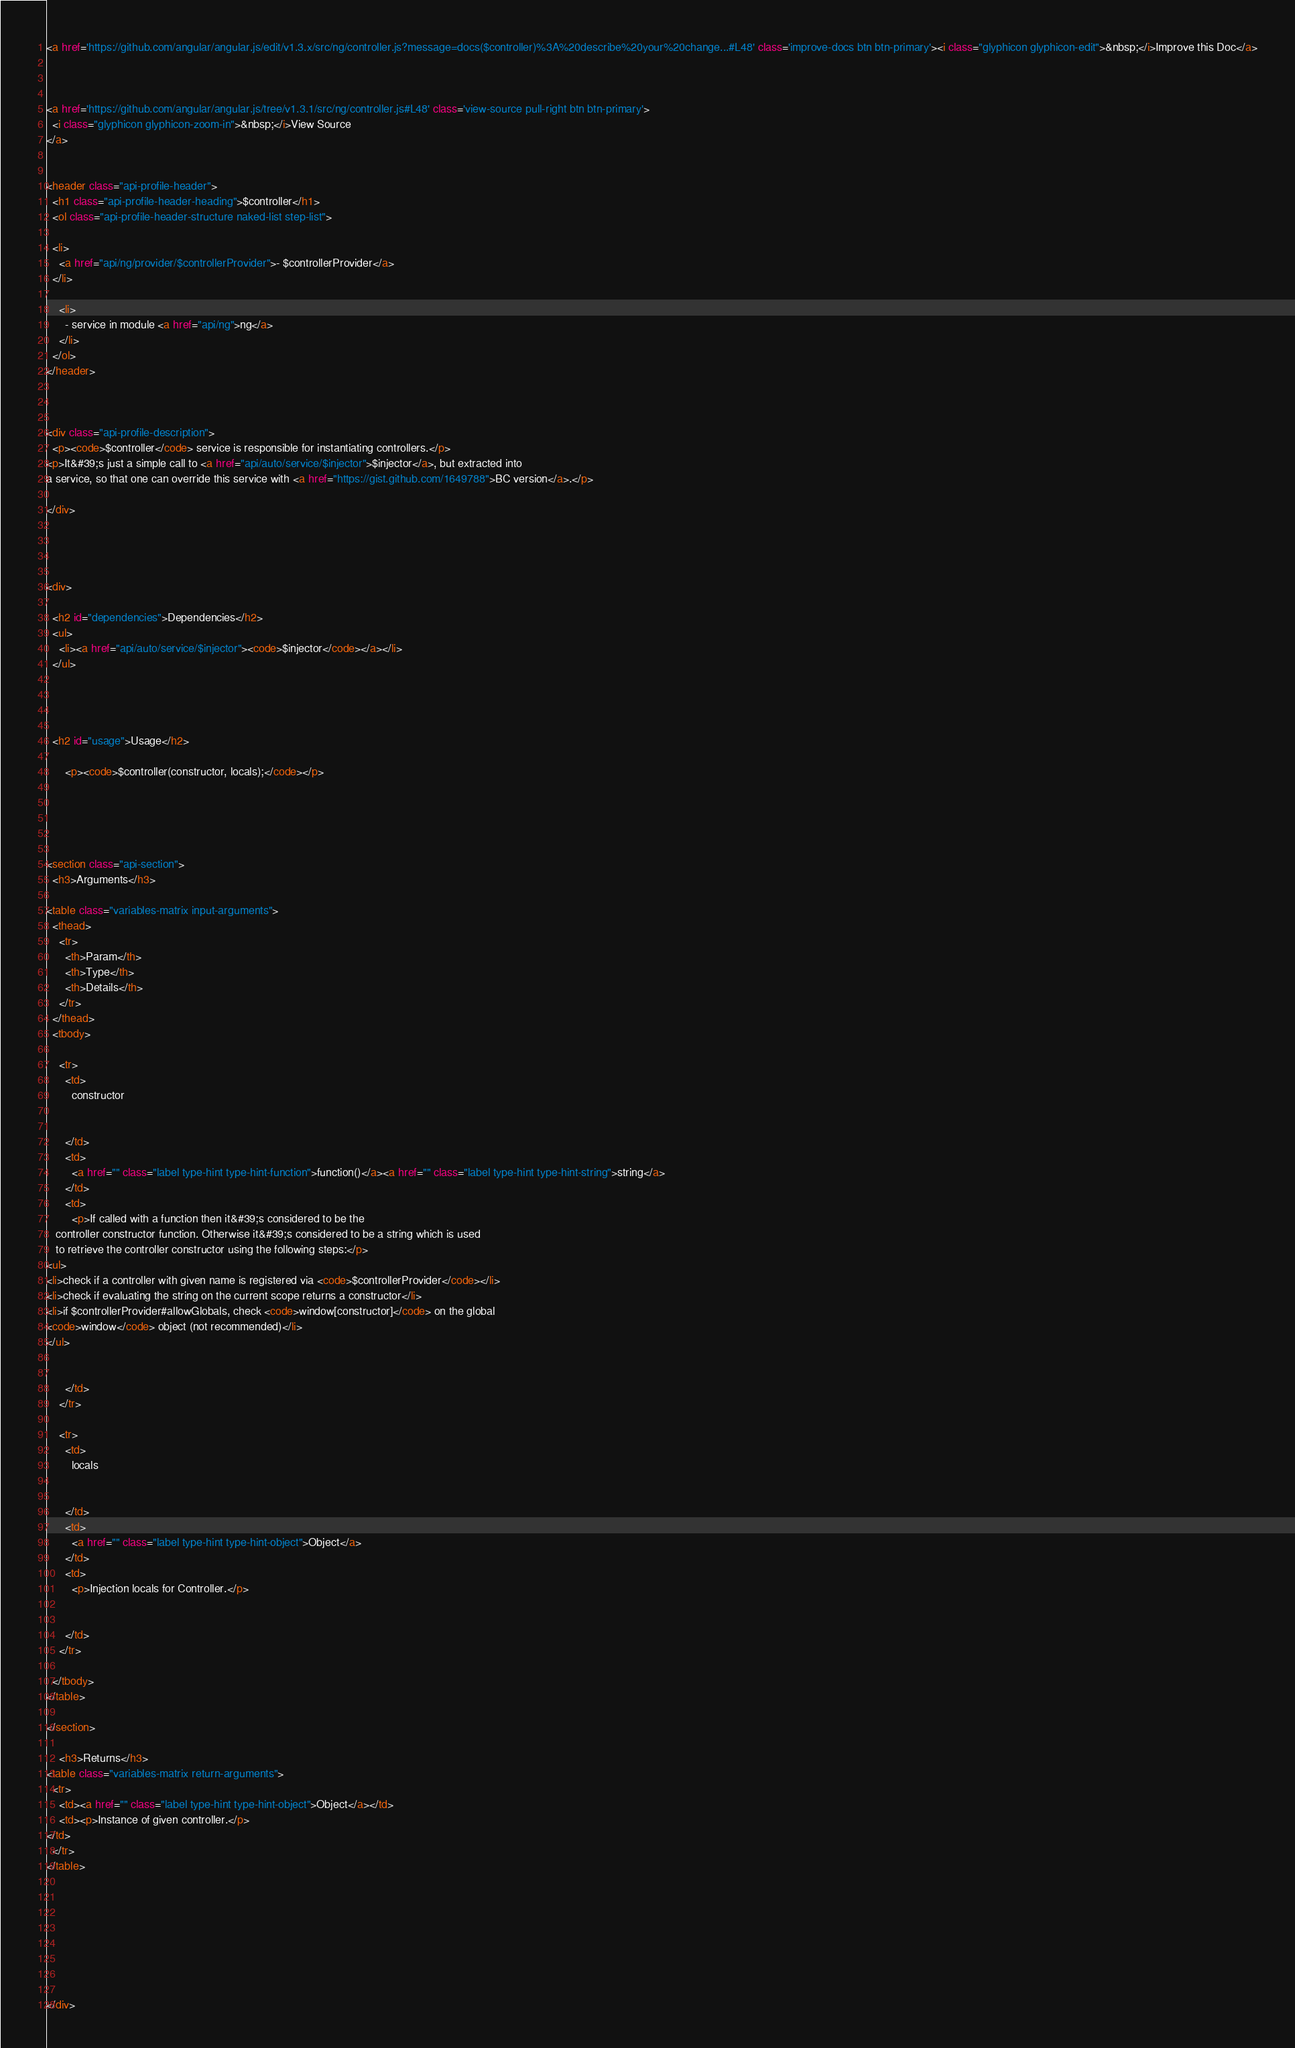Convert code to text. <code><loc_0><loc_0><loc_500><loc_500><_HTML_><a href='https://github.com/angular/angular.js/edit/v1.3.x/src/ng/controller.js?message=docs($controller)%3A%20describe%20your%20change...#L48' class='improve-docs btn btn-primary'><i class="glyphicon glyphicon-edit">&nbsp;</i>Improve this Doc</a>



<a href='https://github.com/angular/angular.js/tree/v1.3.1/src/ng/controller.js#L48' class='view-source pull-right btn btn-primary'>
  <i class="glyphicon glyphicon-zoom-in">&nbsp;</i>View Source
</a>


<header class="api-profile-header">
  <h1 class="api-profile-header-heading">$controller</h1>
  <ol class="api-profile-header-structure naked-list step-list">
    
  <li>
    <a href="api/ng/provider/$controllerProvider">- $controllerProvider</a>
  </li>

    <li>
      - service in module <a href="api/ng">ng</a>
    </li>
  </ol>
</header>



<div class="api-profile-description">
  <p><code>$controller</code> service is responsible for instantiating controllers.</p>
<p>It&#39;s just a simple call to <a href="api/auto/service/$injector">$injector</a>, but extracted into
a service, so that one can override this service with <a href="https://gist.github.com/1649788">BC version</a>.</p>

</div>




<div>
  
  <h2 id="dependencies">Dependencies</h2>
  <ul>
    <li><a href="api/auto/service/$injector"><code>$injector</code></a></li>
  </ul>
  

    

  <h2 id="usage">Usage</h2>
    
      <p><code>$controller(constructor, locals);</code></p>


    

    
<section class="api-section">
  <h3>Arguments</h3>

<table class="variables-matrix input-arguments">
  <thead>
    <tr>
      <th>Param</th>
      <th>Type</th>
      <th>Details</th>
    </tr>
  </thead>
  <tbody>
    
    <tr>
      <td>
        constructor
        
        
      </td>
      <td>
        <a href="" class="label type-hint type-hint-function">function()</a><a href="" class="label type-hint type-hint-string">string</a>
      </td>
      <td>
        <p>If called with a function then it&#39;s considered to be the
   controller constructor function. Otherwise it&#39;s considered to be a string which is used
   to retrieve the controller constructor using the following steps:</p>
<ul>
<li>check if a controller with given name is registered via <code>$controllerProvider</code></li>
<li>check if evaluating the string on the current scope returns a constructor</li>
<li>if $controllerProvider#allowGlobals, check <code>window[constructor]</code> on the global
<code>window</code> object (not recommended)</li>
</ul>

        
      </td>
    </tr>
    
    <tr>
      <td>
        locals
        
        
      </td>
      <td>
        <a href="" class="label type-hint type-hint-object">Object</a>
      </td>
      <td>
        <p>Injection locals for Controller.</p>

        
      </td>
    </tr>
    
  </tbody>
</table>

</section>
    
    <h3>Returns</h3>
<table class="variables-matrix return-arguments">
  <tr>
    <td><a href="" class="label type-hint type-hint-object">Object</a></td>
    <td><p>Instance of given controller.</p>
</td>
  </tr>
</table>

  
  
  



  
</div>


</code> 